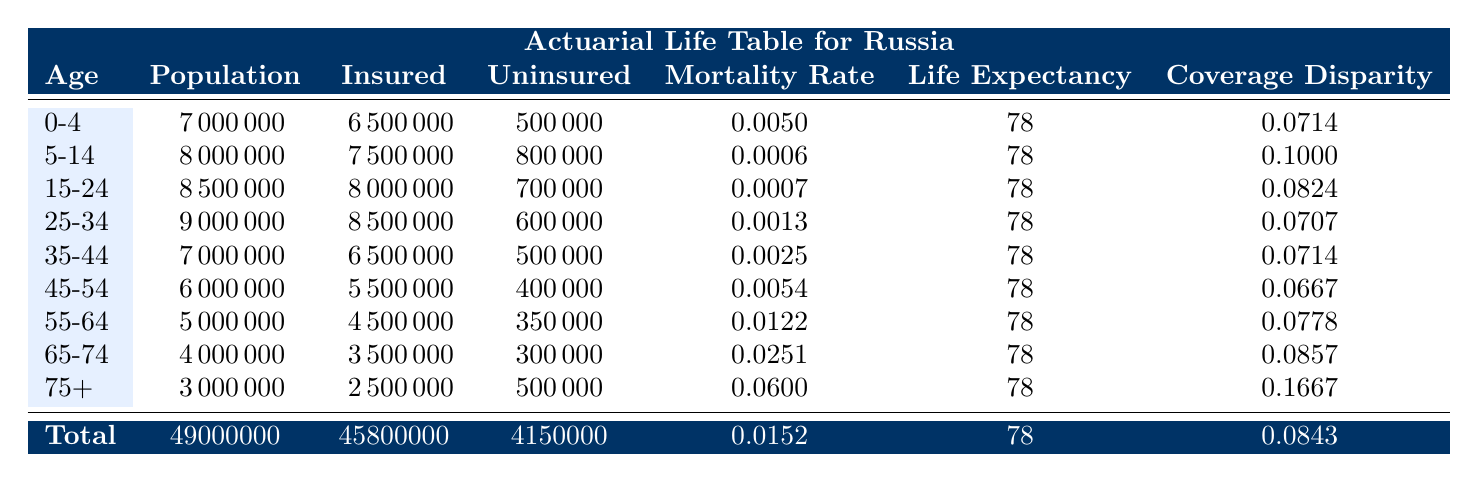What is the total population of the age group 75+? The table shows that the population for the age group 75+ is 3000000.
Answer: 3000000 What age group has the highest mortality rate? Looking at the mortality rates in each age group, 75+ has the highest rate at 0.06.
Answer: 75+ What is the health coverage disparity for the age group 55-64? The health coverage disparity for the age group 55-64 is listed as 0.0778 in the table.
Answer: 0.0778 How many more insured individuals are there than uninsured in the 25-34 age group? In the 25-34 age group, there are 8500000 insured and 600000 uninsured. The difference is 8500000 - 600000 = 7900000.
Answer: 7900000 Is the average life expectancy for all age groups the same? Yes, the table indicates that the average life expectancy for all age groups is 78 years.
Answer: Yes What percentage of the total population is uninsured? The total population is 49000000 and the total uninsured population is 4150000. The percentage uninsured is (4150000 / 49000000) * 100 = 8.47%.
Answer: 8.47% What is the average mortality rate across all age groups? The average mortality rate provided in the table is 0.0152, which is derived from the individual rates across age groups combined.
Answer: 0.0152 For the age group 45-54, what is the difference in population between insured and uninsured? For age group 45-54, there are 5500000 insured and 400000 uninsured. The difference is 5500000 - 400000 = 5100000.
Answer: 5100000 What is the total number of insured people across all age groups? The table states that the total insured population across all age groups is 45800000.
Answer: 45800000 